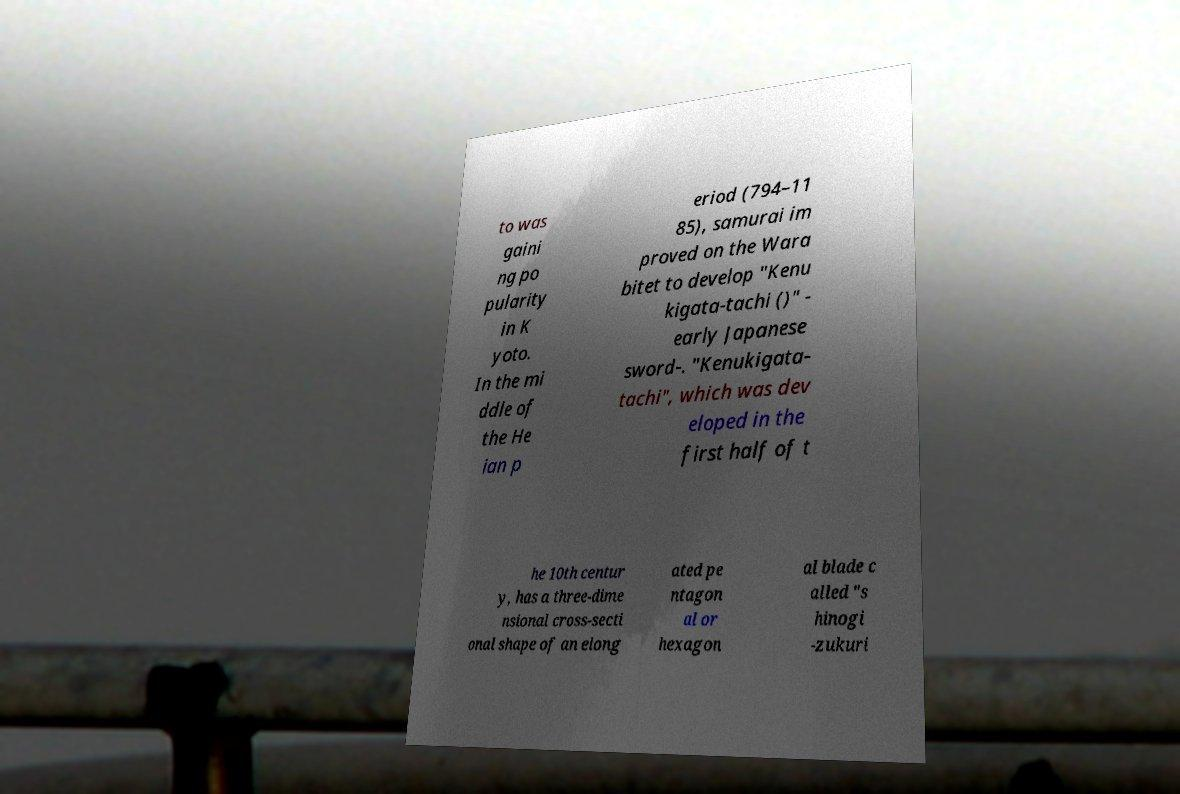Could you assist in decoding the text presented in this image and type it out clearly? to was gaini ng po pularity in K yoto. In the mi ddle of the He ian p eriod (794–11 85), samurai im proved on the Wara bitet to develop "Kenu kigata-tachi ()" - early Japanese sword-. "Kenukigata- tachi", which was dev eloped in the first half of t he 10th centur y, has a three-dime nsional cross-secti onal shape of an elong ated pe ntagon al or hexagon al blade c alled "s hinogi -zukuri 